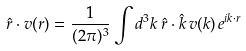Convert formula to latex. <formula><loc_0><loc_0><loc_500><loc_500>\hat { r } \cdot { v } ( { r } ) = \frac { 1 } { ( 2 \pi ) ^ { 3 } } \int d ^ { 3 } { k } \, \hat { r } \cdot \hat { k } \, v ( k ) \, e ^ { i { k } \cdot { r } }</formula> 